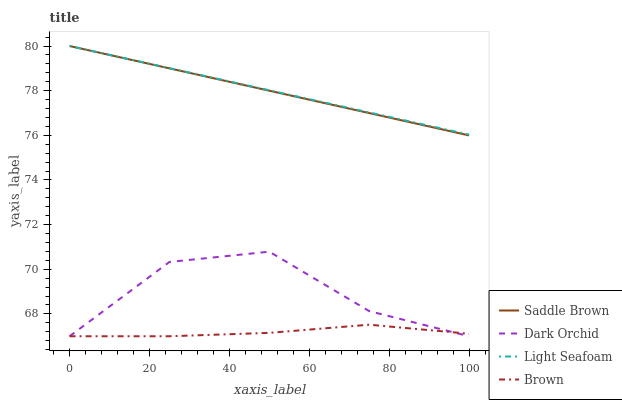Does Brown have the minimum area under the curve?
Answer yes or no. Yes. Does Light Seafoam have the maximum area under the curve?
Answer yes or no. Yes. Does Saddle Brown have the minimum area under the curve?
Answer yes or no. No. Does Saddle Brown have the maximum area under the curve?
Answer yes or no. No. Is Saddle Brown the smoothest?
Answer yes or no. Yes. Is Dark Orchid the roughest?
Answer yes or no. Yes. Is Light Seafoam the smoothest?
Answer yes or no. No. Is Light Seafoam the roughest?
Answer yes or no. No. Does Brown have the lowest value?
Answer yes or no. Yes. Does Saddle Brown have the lowest value?
Answer yes or no. No. Does Saddle Brown have the highest value?
Answer yes or no. Yes. Does Dark Orchid have the highest value?
Answer yes or no. No. Is Brown less than Saddle Brown?
Answer yes or no. Yes. Is Saddle Brown greater than Brown?
Answer yes or no. Yes. Does Saddle Brown intersect Light Seafoam?
Answer yes or no. Yes. Is Saddle Brown less than Light Seafoam?
Answer yes or no. No. Is Saddle Brown greater than Light Seafoam?
Answer yes or no. No. Does Brown intersect Saddle Brown?
Answer yes or no. No. 